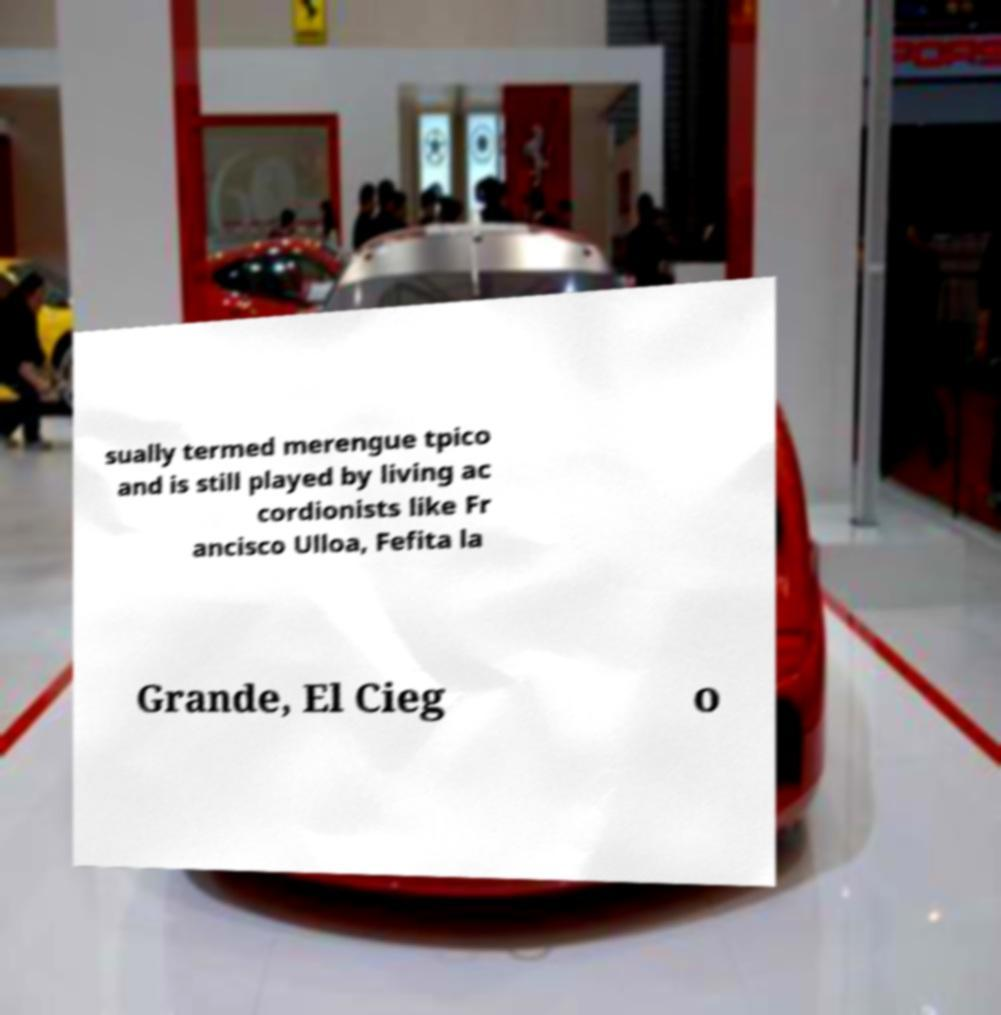Please read and relay the text visible in this image. What does it say? sually termed merengue tpico and is still played by living ac cordionists like Fr ancisco Ulloa, Fefita la Grande, El Cieg o 